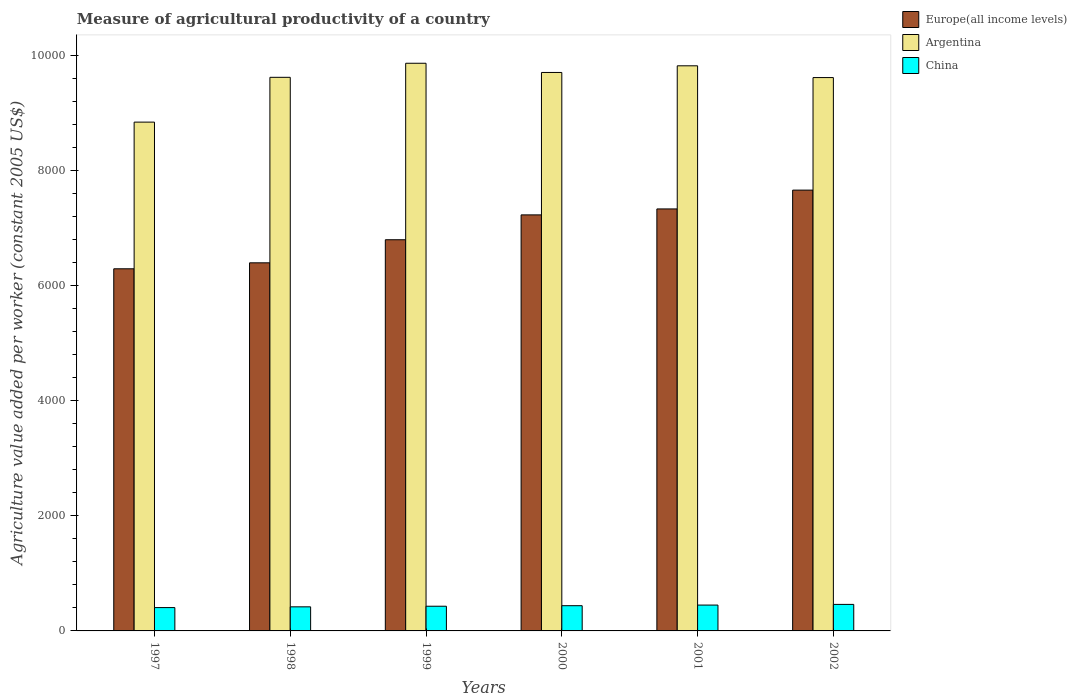How many groups of bars are there?
Offer a very short reply. 6. Are the number of bars on each tick of the X-axis equal?
Provide a succinct answer. Yes. What is the label of the 4th group of bars from the left?
Give a very brief answer. 2000. What is the measure of agricultural productivity in Argentina in 1998?
Provide a succinct answer. 9617.14. Across all years, what is the maximum measure of agricultural productivity in Argentina?
Offer a terse response. 9861.32. Across all years, what is the minimum measure of agricultural productivity in Argentina?
Keep it short and to the point. 8838.88. In which year was the measure of agricultural productivity in Argentina maximum?
Keep it short and to the point. 1999. What is the total measure of agricultural productivity in Europe(all income levels) in the graph?
Provide a succinct answer. 4.17e+04. What is the difference between the measure of agricultural productivity in China in 1998 and that in 2001?
Provide a short and direct response. -30.78. What is the difference between the measure of agricultural productivity in Europe(all income levels) in 1998 and the measure of agricultural productivity in Argentina in 2001?
Ensure brevity in your answer.  -3422.39. What is the average measure of agricultural productivity in Europe(all income levels) per year?
Your answer should be very brief. 6949.44. In the year 1999, what is the difference between the measure of agricultural productivity in China and measure of agricultural productivity in Argentina?
Your response must be concise. -9432.34. What is the ratio of the measure of agricultural productivity in Argentina in 1998 to that in 1999?
Provide a short and direct response. 0.98. Is the measure of agricultural productivity in Europe(all income levels) in 1998 less than that in 2001?
Your answer should be compact. Yes. What is the difference between the highest and the second highest measure of agricultural productivity in Argentina?
Give a very brief answer. 44.26. What is the difference between the highest and the lowest measure of agricultural productivity in Europe(all income levels)?
Provide a short and direct response. 1366.71. Is the sum of the measure of agricultural productivity in China in 1999 and 2002 greater than the maximum measure of agricultural productivity in Argentina across all years?
Your response must be concise. No. What does the 3rd bar from the left in 2001 represents?
Ensure brevity in your answer.  China. What does the 3rd bar from the right in 2001 represents?
Offer a terse response. Europe(all income levels). How many bars are there?
Provide a short and direct response. 18. How many years are there in the graph?
Your response must be concise. 6. What is the difference between two consecutive major ticks on the Y-axis?
Offer a very short reply. 2000. Are the values on the major ticks of Y-axis written in scientific E-notation?
Your answer should be compact. No. Does the graph contain any zero values?
Your answer should be compact. No. Where does the legend appear in the graph?
Keep it short and to the point. Top right. How many legend labels are there?
Make the answer very short. 3. How are the legend labels stacked?
Provide a succinct answer. Vertical. What is the title of the graph?
Offer a very short reply. Measure of agricultural productivity of a country. What is the label or title of the Y-axis?
Make the answer very short. Agriculture value added per worker (constant 2005 US$). What is the Agriculture value added per worker (constant 2005 US$) in Europe(all income levels) in 1997?
Provide a short and direct response. 6290.86. What is the Agriculture value added per worker (constant 2005 US$) in Argentina in 1997?
Your answer should be compact. 8838.88. What is the Agriculture value added per worker (constant 2005 US$) of China in 1997?
Offer a very short reply. 405.37. What is the Agriculture value added per worker (constant 2005 US$) in Europe(all income levels) in 1998?
Your answer should be very brief. 6394.67. What is the Agriculture value added per worker (constant 2005 US$) of Argentina in 1998?
Your answer should be compact. 9617.14. What is the Agriculture value added per worker (constant 2005 US$) in China in 1998?
Provide a succinct answer. 418.34. What is the Agriculture value added per worker (constant 2005 US$) of Europe(all income levels) in 1999?
Your answer should be compact. 6795.55. What is the Agriculture value added per worker (constant 2005 US$) in Argentina in 1999?
Offer a terse response. 9861.32. What is the Agriculture value added per worker (constant 2005 US$) of China in 1999?
Your response must be concise. 428.98. What is the Agriculture value added per worker (constant 2005 US$) of Europe(all income levels) in 2000?
Keep it short and to the point. 7227.25. What is the Agriculture value added per worker (constant 2005 US$) in Argentina in 2000?
Provide a short and direct response. 9701.56. What is the Agriculture value added per worker (constant 2005 US$) of China in 2000?
Your answer should be very brief. 438.12. What is the Agriculture value added per worker (constant 2005 US$) in Europe(all income levels) in 2001?
Provide a short and direct response. 7330.74. What is the Agriculture value added per worker (constant 2005 US$) of Argentina in 2001?
Your answer should be very brief. 9817.06. What is the Agriculture value added per worker (constant 2005 US$) of China in 2001?
Your answer should be very brief. 449.12. What is the Agriculture value added per worker (constant 2005 US$) in Europe(all income levels) in 2002?
Your response must be concise. 7657.57. What is the Agriculture value added per worker (constant 2005 US$) of Argentina in 2002?
Ensure brevity in your answer.  9612.59. What is the Agriculture value added per worker (constant 2005 US$) in China in 2002?
Give a very brief answer. 460.74. Across all years, what is the maximum Agriculture value added per worker (constant 2005 US$) in Europe(all income levels)?
Your answer should be compact. 7657.57. Across all years, what is the maximum Agriculture value added per worker (constant 2005 US$) of Argentina?
Give a very brief answer. 9861.32. Across all years, what is the maximum Agriculture value added per worker (constant 2005 US$) in China?
Offer a very short reply. 460.74. Across all years, what is the minimum Agriculture value added per worker (constant 2005 US$) of Europe(all income levels)?
Ensure brevity in your answer.  6290.86. Across all years, what is the minimum Agriculture value added per worker (constant 2005 US$) in Argentina?
Give a very brief answer. 8838.88. Across all years, what is the minimum Agriculture value added per worker (constant 2005 US$) of China?
Provide a succinct answer. 405.37. What is the total Agriculture value added per worker (constant 2005 US$) of Europe(all income levels) in the graph?
Offer a very short reply. 4.17e+04. What is the total Agriculture value added per worker (constant 2005 US$) in Argentina in the graph?
Your response must be concise. 5.74e+04. What is the total Agriculture value added per worker (constant 2005 US$) of China in the graph?
Your answer should be compact. 2600.67. What is the difference between the Agriculture value added per worker (constant 2005 US$) in Europe(all income levels) in 1997 and that in 1998?
Your answer should be very brief. -103.82. What is the difference between the Agriculture value added per worker (constant 2005 US$) in Argentina in 1997 and that in 1998?
Provide a short and direct response. -778.27. What is the difference between the Agriculture value added per worker (constant 2005 US$) of China in 1997 and that in 1998?
Offer a very short reply. -12.97. What is the difference between the Agriculture value added per worker (constant 2005 US$) in Europe(all income levels) in 1997 and that in 1999?
Ensure brevity in your answer.  -504.7. What is the difference between the Agriculture value added per worker (constant 2005 US$) in Argentina in 1997 and that in 1999?
Ensure brevity in your answer.  -1022.44. What is the difference between the Agriculture value added per worker (constant 2005 US$) in China in 1997 and that in 1999?
Keep it short and to the point. -23.61. What is the difference between the Agriculture value added per worker (constant 2005 US$) of Europe(all income levels) in 1997 and that in 2000?
Your answer should be compact. -936.4. What is the difference between the Agriculture value added per worker (constant 2005 US$) in Argentina in 1997 and that in 2000?
Keep it short and to the point. -862.69. What is the difference between the Agriculture value added per worker (constant 2005 US$) of China in 1997 and that in 2000?
Provide a short and direct response. -32.76. What is the difference between the Agriculture value added per worker (constant 2005 US$) in Europe(all income levels) in 1997 and that in 2001?
Make the answer very short. -1039.88. What is the difference between the Agriculture value added per worker (constant 2005 US$) in Argentina in 1997 and that in 2001?
Ensure brevity in your answer.  -978.18. What is the difference between the Agriculture value added per worker (constant 2005 US$) of China in 1997 and that in 2001?
Give a very brief answer. -43.75. What is the difference between the Agriculture value added per worker (constant 2005 US$) in Europe(all income levels) in 1997 and that in 2002?
Your answer should be compact. -1366.71. What is the difference between the Agriculture value added per worker (constant 2005 US$) in Argentina in 1997 and that in 2002?
Your answer should be very brief. -773.71. What is the difference between the Agriculture value added per worker (constant 2005 US$) of China in 1997 and that in 2002?
Give a very brief answer. -55.38. What is the difference between the Agriculture value added per worker (constant 2005 US$) of Europe(all income levels) in 1998 and that in 1999?
Offer a terse response. -400.88. What is the difference between the Agriculture value added per worker (constant 2005 US$) in Argentina in 1998 and that in 1999?
Offer a very short reply. -244.18. What is the difference between the Agriculture value added per worker (constant 2005 US$) in China in 1998 and that in 1999?
Your answer should be very brief. -10.64. What is the difference between the Agriculture value added per worker (constant 2005 US$) of Europe(all income levels) in 1998 and that in 2000?
Your answer should be compact. -832.58. What is the difference between the Agriculture value added per worker (constant 2005 US$) in Argentina in 1998 and that in 2000?
Your response must be concise. -84.42. What is the difference between the Agriculture value added per worker (constant 2005 US$) in China in 1998 and that in 2000?
Your answer should be compact. -19.78. What is the difference between the Agriculture value added per worker (constant 2005 US$) in Europe(all income levels) in 1998 and that in 2001?
Provide a short and direct response. -936.06. What is the difference between the Agriculture value added per worker (constant 2005 US$) in Argentina in 1998 and that in 2001?
Your answer should be very brief. -199.92. What is the difference between the Agriculture value added per worker (constant 2005 US$) in China in 1998 and that in 2001?
Offer a very short reply. -30.78. What is the difference between the Agriculture value added per worker (constant 2005 US$) in Europe(all income levels) in 1998 and that in 2002?
Provide a succinct answer. -1262.9. What is the difference between the Agriculture value added per worker (constant 2005 US$) in Argentina in 1998 and that in 2002?
Keep it short and to the point. 4.55. What is the difference between the Agriculture value added per worker (constant 2005 US$) of China in 1998 and that in 2002?
Your answer should be compact. -42.41. What is the difference between the Agriculture value added per worker (constant 2005 US$) of Europe(all income levels) in 1999 and that in 2000?
Offer a terse response. -431.7. What is the difference between the Agriculture value added per worker (constant 2005 US$) in Argentina in 1999 and that in 2000?
Your response must be concise. 159.75. What is the difference between the Agriculture value added per worker (constant 2005 US$) of China in 1999 and that in 2000?
Make the answer very short. -9.14. What is the difference between the Agriculture value added per worker (constant 2005 US$) of Europe(all income levels) in 1999 and that in 2001?
Offer a terse response. -535.18. What is the difference between the Agriculture value added per worker (constant 2005 US$) of Argentina in 1999 and that in 2001?
Provide a succinct answer. 44.26. What is the difference between the Agriculture value added per worker (constant 2005 US$) in China in 1999 and that in 2001?
Ensure brevity in your answer.  -20.14. What is the difference between the Agriculture value added per worker (constant 2005 US$) in Europe(all income levels) in 1999 and that in 2002?
Make the answer very short. -862.02. What is the difference between the Agriculture value added per worker (constant 2005 US$) in Argentina in 1999 and that in 2002?
Offer a very short reply. 248.73. What is the difference between the Agriculture value added per worker (constant 2005 US$) of China in 1999 and that in 2002?
Ensure brevity in your answer.  -31.77. What is the difference between the Agriculture value added per worker (constant 2005 US$) in Europe(all income levels) in 2000 and that in 2001?
Your answer should be very brief. -103.48. What is the difference between the Agriculture value added per worker (constant 2005 US$) in Argentina in 2000 and that in 2001?
Keep it short and to the point. -115.5. What is the difference between the Agriculture value added per worker (constant 2005 US$) in China in 2000 and that in 2001?
Give a very brief answer. -11. What is the difference between the Agriculture value added per worker (constant 2005 US$) of Europe(all income levels) in 2000 and that in 2002?
Your answer should be compact. -430.32. What is the difference between the Agriculture value added per worker (constant 2005 US$) in Argentina in 2000 and that in 2002?
Your answer should be compact. 88.97. What is the difference between the Agriculture value added per worker (constant 2005 US$) in China in 2000 and that in 2002?
Your answer should be very brief. -22.62. What is the difference between the Agriculture value added per worker (constant 2005 US$) of Europe(all income levels) in 2001 and that in 2002?
Make the answer very short. -326.84. What is the difference between the Agriculture value added per worker (constant 2005 US$) of Argentina in 2001 and that in 2002?
Make the answer very short. 204.47. What is the difference between the Agriculture value added per worker (constant 2005 US$) in China in 2001 and that in 2002?
Your answer should be compact. -11.62. What is the difference between the Agriculture value added per worker (constant 2005 US$) in Europe(all income levels) in 1997 and the Agriculture value added per worker (constant 2005 US$) in Argentina in 1998?
Your answer should be compact. -3326.29. What is the difference between the Agriculture value added per worker (constant 2005 US$) in Europe(all income levels) in 1997 and the Agriculture value added per worker (constant 2005 US$) in China in 1998?
Your answer should be compact. 5872.52. What is the difference between the Agriculture value added per worker (constant 2005 US$) of Argentina in 1997 and the Agriculture value added per worker (constant 2005 US$) of China in 1998?
Ensure brevity in your answer.  8420.54. What is the difference between the Agriculture value added per worker (constant 2005 US$) of Europe(all income levels) in 1997 and the Agriculture value added per worker (constant 2005 US$) of Argentina in 1999?
Ensure brevity in your answer.  -3570.46. What is the difference between the Agriculture value added per worker (constant 2005 US$) in Europe(all income levels) in 1997 and the Agriculture value added per worker (constant 2005 US$) in China in 1999?
Make the answer very short. 5861.88. What is the difference between the Agriculture value added per worker (constant 2005 US$) in Argentina in 1997 and the Agriculture value added per worker (constant 2005 US$) in China in 1999?
Give a very brief answer. 8409.9. What is the difference between the Agriculture value added per worker (constant 2005 US$) of Europe(all income levels) in 1997 and the Agriculture value added per worker (constant 2005 US$) of Argentina in 2000?
Give a very brief answer. -3410.71. What is the difference between the Agriculture value added per worker (constant 2005 US$) in Europe(all income levels) in 1997 and the Agriculture value added per worker (constant 2005 US$) in China in 2000?
Your answer should be very brief. 5852.73. What is the difference between the Agriculture value added per worker (constant 2005 US$) in Argentina in 1997 and the Agriculture value added per worker (constant 2005 US$) in China in 2000?
Ensure brevity in your answer.  8400.75. What is the difference between the Agriculture value added per worker (constant 2005 US$) in Europe(all income levels) in 1997 and the Agriculture value added per worker (constant 2005 US$) in Argentina in 2001?
Offer a terse response. -3526.2. What is the difference between the Agriculture value added per worker (constant 2005 US$) in Europe(all income levels) in 1997 and the Agriculture value added per worker (constant 2005 US$) in China in 2001?
Your answer should be very brief. 5841.74. What is the difference between the Agriculture value added per worker (constant 2005 US$) of Argentina in 1997 and the Agriculture value added per worker (constant 2005 US$) of China in 2001?
Offer a very short reply. 8389.76. What is the difference between the Agriculture value added per worker (constant 2005 US$) of Europe(all income levels) in 1997 and the Agriculture value added per worker (constant 2005 US$) of Argentina in 2002?
Ensure brevity in your answer.  -3321.73. What is the difference between the Agriculture value added per worker (constant 2005 US$) in Europe(all income levels) in 1997 and the Agriculture value added per worker (constant 2005 US$) in China in 2002?
Make the answer very short. 5830.11. What is the difference between the Agriculture value added per worker (constant 2005 US$) of Argentina in 1997 and the Agriculture value added per worker (constant 2005 US$) of China in 2002?
Your answer should be very brief. 8378.13. What is the difference between the Agriculture value added per worker (constant 2005 US$) in Europe(all income levels) in 1998 and the Agriculture value added per worker (constant 2005 US$) in Argentina in 1999?
Your response must be concise. -3466.64. What is the difference between the Agriculture value added per worker (constant 2005 US$) of Europe(all income levels) in 1998 and the Agriculture value added per worker (constant 2005 US$) of China in 1999?
Your answer should be very brief. 5965.69. What is the difference between the Agriculture value added per worker (constant 2005 US$) of Argentina in 1998 and the Agriculture value added per worker (constant 2005 US$) of China in 1999?
Your answer should be very brief. 9188.16. What is the difference between the Agriculture value added per worker (constant 2005 US$) of Europe(all income levels) in 1998 and the Agriculture value added per worker (constant 2005 US$) of Argentina in 2000?
Your answer should be compact. -3306.89. What is the difference between the Agriculture value added per worker (constant 2005 US$) of Europe(all income levels) in 1998 and the Agriculture value added per worker (constant 2005 US$) of China in 2000?
Your answer should be very brief. 5956.55. What is the difference between the Agriculture value added per worker (constant 2005 US$) of Argentina in 1998 and the Agriculture value added per worker (constant 2005 US$) of China in 2000?
Keep it short and to the point. 9179.02. What is the difference between the Agriculture value added per worker (constant 2005 US$) in Europe(all income levels) in 1998 and the Agriculture value added per worker (constant 2005 US$) in Argentina in 2001?
Offer a very short reply. -3422.39. What is the difference between the Agriculture value added per worker (constant 2005 US$) of Europe(all income levels) in 1998 and the Agriculture value added per worker (constant 2005 US$) of China in 2001?
Give a very brief answer. 5945.55. What is the difference between the Agriculture value added per worker (constant 2005 US$) of Argentina in 1998 and the Agriculture value added per worker (constant 2005 US$) of China in 2001?
Your response must be concise. 9168.02. What is the difference between the Agriculture value added per worker (constant 2005 US$) in Europe(all income levels) in 1998 and the Agriculture value added per worker (constant 2005 US$) in Argentina in 2002?
Your answer should be compact. -3217.92. What is the difference between the Agriculture value added per worker (constant 2005 US$) of Europe(all income levels) in 1998 and the Agriculture value added per worker (constant 2005 US$) of China in 2002?
Your answer should be very brief. 5933.93. What is the difference between the Agriculture value added per worker (constant 2005 US$) of Argentina in 1998 and the Agriculture value added per worker (constant 2005 US$) of China in 2002?
Ensure brevity in your answer.  9156.4. What is the difference between the Agriculture value added per worker (constant 2005 US$) in Europe(all income levels) in 1999 and the Agriculture value added per worker (constant 2005 US$) in Argentina in 2000?
Your response must be concise. -2906.01. What is the difference between the Agriculture value added per worker (constant 2005 US$) of Europe(all income levels) in 1999 and the Agriculture value added per worker (constant 2005 US$) of China in 2000?
Keep it short and to the point. 6357.43. What is the difference between the Agriculture value added per worker (constant 2005 US$) in Argentina in 1999 and the Agriculture value added per worker (constant 2005 US$) in China in 2000?
Your response must be concise. 9423.2. What is the difference between the Agriculture value added per worker (constant 2005 US$) in Europe(all income levels) in 1999 and the Agriculture value added per worker (constant 2005 US$) in Argentina in 2001?
Ensure brevity in your answer.  -3021.51. What is the difference between the Agriculture value added per worker (constant 2005 US$) of Europe(all income levels) in 1999 and the Agriculture value added per worker (constant 2005 US$) of China in 2001?
Keep it short and to the point. 6346.43. What is the difference between the Agriculture value added per worker (constant 2005 US$) of Argentina in 1999 and the Agriculture value added per worker (constant 2005 US$) of China in 2001?
Offer a very short reply. 9412.2. What is the difference between the Agriculture value added per worker (constant 2005 US$) of Europe(all income levels) in 1999 and the Agriculture value added per worker (constant 2005 US$) of Argentina in 2002?
Keep it short and to the point. -2817.04. What is the difference between the Agriculture value added per worker (constant 2005 US$) in Europe(all income levels) in 1999 and the Agriculture value added per worker (constant 2005 US$) in China in 2002?
Make the answer very short. 6334.81. What is the difference between the Agriculture value added per worker (constant 2005 US$) in Argentina in 1999 and the Agriculture value added per worker (constant 2005 US$) in China in 2002?
Offer a very short reply. 9400.57. What is the difference between the Agriculture value added per worker (constant 2005 US$) in Europe(all income levels) in 2000 and the Agriculture value added per worker (constant 2005 US$) in Argentina in 2001?
Offer a terse response. -2589.81. What is the difference between the Agriculture value added per worker (constant 2005 US$) of Europe(all income levels) in 2000 and the Agriculture value added per worker (constant 2005 US$) of China in 2001?
Ensure brevity in your answer.  6778.13. What is the difference between the Agriculture value added per worker (constant 2005 US$) of Argentina in 2000 and the Agriculture value added per worker (constant 2005 US$) of China in 2001?
Your response must be concise. 9252.44. What is the difference between the Agriculture value added per worker (constant 2005 US$) in Europe(all income levels) in 2000 and the Agriculture value added per worker (constant 2005 US$) in Argentina in 2002?
Make the answer very short. -2385.34. What is the difference between the Agriculture value added per worker (constant 2005 US$) of Europe(all income levels) in 2000 and the Agriculture value added per worker (constant 2005 US$) of China in 2002?
Keep it short and to the point. 6766.51. What is the difference between the Agriculture value added per worker (constant 2005 US$) of Argentina in 2000 and the Agriculture value added per worker (constant 2005 US$) of China in 2002?
Offer a terse response. 9240.82. What is the difference between the Agriculture value added per worker (constant 2005 US$) in Europe(all income levels) in 2001 and the Agriculture value added per worker (constant 2005 US$) in Argentina in 2002?
Make the answer very short. -2281.85. What is the difference between the Agriculture value added per worker (constant 2005 US$) in Europe(all income levels) in 2001 and the Agriculture value added per worker (constant 2005 US$) in China in 2002?
Make the answer very short. 6869.99. What is the difference between the Agriculture value added per worker (constant 2005 US$) in Argentina in 2001 and the Agriculture value added per worker (constant 2005 US$) in China in 2002?
Ensure brevity in your answer.  9356.32. What is the average Agriculture value added per worker (constant 2005 US$) in Europe(all income levels) per year?
Offer a very short reply. 6949.44. What is the average Agriculture value added per worker (constant 2005 US$) of Argentina per year?
Your answer should be very brief. 9574.76. What is the average Agriculture value added per worker (constant 2005 US$) in China per year?
Provide a succinct answer. 433.44. In the year 1997, what is the difference between the Agriculture value added per worker (constant 2005 US$) in Europe(all income levels) and Agriculture value added per worker (constant 2005 US$) in Argentina?
Keep it short and to the point. -2548.02. In the year 1997, what is the difference between the Agriculture value added per worker (constant 2005 US$) in Europe(all income levels) and Agriculture value added per worker (constant 2005 US$) in China?
Your response must be concise. 5885.49. In the year 1997, what is the difference between the Agriculture value added per worker (constant 2005 US$) in Argentina and Agriculture value added per worker (constant 2005 US$) in China?
Make the answer very short. 8433.51. In the year 1998, what is the difference between the Agriculture value added per worker (constant 2005 US$) in Europe(all income levels) and Agriculture value added per worker (constant 2005 US$) in Argentina?
Offer a very short reply. -3222.47. In the year 1998, what is the difference between the Agriculture value added per worker (constant 2005 US$) of Europe(all income levels) and Agriculture value added per worker (constant 2005 US$) of China?
Provide a short and direct response. 5976.34. In the year 1998, what is the difference between the Agriculture value added per worker (constant 2005 US$) in Argentina and Agriculture value added per worker (constant 2005 US$) in China?
Your answer should be very brief. 9198.8. In the year 1999, what is the difference between the Agriculture value added per worker (constant 2005 US$) of Europe(all income levels) and Agriculture value added per worker (constant 2005 US$) of Argentina?
Keep it short and to the point. -3065.77. In the year 1999, what is the difference between the Agriculture value added per worker (constant 2005 US$) in Europe(all income levels) and Agriculture value added per worker (constant 2005 US$) in China?
Your answer should be compact. 6366.57. In the year 1999, what is the difference between the Agriculture value added per worker (constant 2005 US$) of Argentina and Agriculture value added per worker (constant 2005 US$) of China?
Your response must be concise. 9432.34. In the year 2000, what is the difference between the Agriculture value added per worker (constant 2005 US$) of Europe(all income levels) and Agriculture value added per worker (constant 2005 US$) of Argentina?
Ensure brevity in your answer.  -2474.31. In the year 2000, what is the difference between the Agriculture value added per worker (constant 2005 US$) in Europe(all income levels) and Agriculture value added per worker (constant 2005 US$) in China?
Keep it short and to the point. 6789.13. In the year 2000, what is the difference between the Agriculture value added per worker (constant 2005 US$) in Argentina and Agriculture value added per worker (constant 2005 US$) in China?
Your answer should be very brief. 9263.44. In the year 2001, what is the difference between the Agriculture value added per worker (constant 2005 US$) of Europe(all income levels) and Agriculture value added per worker (constant 2005 US$) of Argentina?
Provide a short and direct response. -2486.32. In the year 2001, what is the difference between the Agriculture value added per worker (constant 2005 US$) of Europe(all income levels) and Agriculture value added per worker (constant 2005 US$) of China?
Provide a short and direct response. 6881.62. In the year 2001, what is the difference between the Agriculture value added per worker (constant 2005 US$) in Argentina and Agriculture value added per worker (constant 2005 US$) in China?
Offer a terse response. 9367.94. In the year 2002, what is the difference between the Agriculture value added per worker (constant 2005 US$) of Europe(all income levels) and Agriculture value added per worker (constant 2005 US$) of Argentina?
Keep it short and to the point. -1955.02. In the year 2002, what is the difference between the Agriculture value added per worker (constant 2005 US$) in Europe(all income levels) and Agriculture value added per worker (constant 2005 US$) in China?
Your response must be concise. 7196.83. In the year 2002, what is the difference between the Agriculture value added per worker (constant 2005 US$) of Argentina and Agriculture value added per worker (constant 2005 US$) of China?
Keep it short and to the point. 9151.85. What is the ratio of the Agriculture value added per worker (constant 2005 US$) of Europe(all income levels) in 1997 to that in 1998?
Your answer should be very brief. 0.98. What is the ratio of the Agriculture value added per worker (constant 2005 US$) of Argentina in 1997 to that in 1998?
Provide a succinct answer. 0.92. What is the ratio of the Agriculture value added per worker (constant 2005 US$) of China in 1997 to that in 1998?
Ensure brevity in your answer.  0.97. What is the ratio of the Agriculture value added per worker (constant 2005 US$) of Europe(all income levels) in 1997 to that in 1999?
Ensure brevity in your answer.  0.93. What is the ratio of the Agriculture value added per worker (constant 2005 US$) of Argentina in 1997 to that in 1999?
Provide a succinct answer. 0.9. What is the ratio of the Agriculture value added per worker (constant 2005 US$) in China in 1997 to that in 1999?
Your answer should be compact. 0.94. What is the ratio of the Agriculture value added per worker (constant 2005 US$) of Europe(all income levels) in 1997 to that in 2000?
Provide a short and direct response. 0.87. What is the ratio of the Agriculture value added per worker (constant 2005 US$) of Argentina in 1997 to that in 2000?
Your answer should be compact. 0.91. What is the ratio of the Agriculture value added per worker (constant 2005 US$) in China in 1997 to that in 2000?
Your response must be concise. 0.93. What is the ratio of the Agriculture value added per worker (constant 2005 US$) in Europe(all income levels) in 1997 to that in 2001?
Your answer should be compact. 0.86. What is the ratio of the Agriculture value added per worker (constant 2005 US$) in Argentina in 1997 to that in 2001?
Ensure brevity in your answer.  0.9. What is the ratio of the Agriculture value added per worker (constant 2005 US$) in China in 1997 to that in 2001?
Offer a terse response. 0.9. What is the ratio of the Agriculture value added per worker (constant 2005 US$) of Europe(all income levels) in 1997 to that in 2002?
Provide a short and direct response. 0.82. What is the ratio of the Agriculture value added per worker (constant 2005 US$) in Argentina in 1997 to that in 2002?
Offer a terse response. 0.92. What is the ratio of the Agriculture value added per worker (constant 2005 US$) of China in 1997 to that in 2002?
Offer a very short reply. 0.88. What is the ratio of the Agriculture value added per worker (constant 2005 US$) of Europe(all income levels) in 1998 to that in 1999?
Make the answer very short. 0.94. What is the ratio of the Agriculture value added per worker (constant 2005 US$) in Argentina in 1998 to that in 1999?
Make the answer very short. 0.98. What is the ratio of the Agriculture value added per worker (constant 2005 US$) of China in 1998 to that in 1999?
Your answer should be very brief. 0.98. What is the ratio of the Agriculture value added per worker (constant 2005 US$) of Europe(all income levels) in 1998 to that in 2000?
Make the answer very short. 0.88. What is the ratio of the Agriculture value added per worker (constant 2005 US$) in China in 1998 to that in 2000?
Your answer should be compact. 0.95. What is the ratio of the Agriculture value added per worker (constant 2005 US$) in Europe(all income levels) in 1998 to that in 2001?
Your answer should be very brief. 0.87. What is the ratio of the Agriculture value added per worker (constant 2005 US$) of Argentina in 1998 to that in 2001?
Your response must be concise. 0.98. What is the ratio of the Agriculture value added per worker (constant 2005 US$) in China in 1998 to that in 2001?
Offer a terse response. 0.93. What is the ratio of the Agriculture value added per worker (constant 2005 US$) in Europe(all income levels) in 1998 to that in 2002?
Provide a short and direct response. 0.84. What is the ratio of the Agriculture value added per worker (constant 2005 US$) of Argentina in 1998 to that in 2002?
Give a very brief answer. 1. What is the ratio of the Agriculture value added per worker (constant 2005 US$) of China in 1998 to that in 2002?
Your answer should be very brief. 0.91. What is the ratio of the Agriculture value added per worker (constant 2005 US$) of Europe(all income levels) in 1999 to that in 2000?
Offer a terse response. 0.94. What is the ratio of the Agriculture value added per worker (constant 2005 US$) of Argentina in 1999 to that in 2000?
Offer a terse response. 1.02. What is the ratio of the Agriculture value added per worker (constant 2005 US$) of China in 1999 to that in 2000?
Offer a terse response. 0.98. What is the ratio of the Agriculture value added per worker (constant 2005 US$) in Europe(all income levels) in 1999 to that in 2001?
Keep it short and to the point. 0.93. What is the ratio of the Agriculture value added per worker (constant 2005 US$) in Argentina in 1999 to that in 2001?
Provide a succinct answer. 1. What is the ratio of the Agriculture value added per worker (constant 2005 US$) in China in 1999 to that in 2001?
Your answer should be very brief. 0.96. What is the ratio of the Agriculture value added per worker (constant 2005 US$) of Europe(all income levels) in 1999 to that in 2002?
Make the answer very short. 0.89. What is the ratio of the Agriculture value added per worker (constant 2005 US$) of Argentina in 1999 to that in 2002?
Provide a short and direct response. 1.03. What is the ratio of the Agriculture value added per worker (constant 2005 US$) of China in 1999 to that in 2002?
Your answer should be very brief. 0.93. What is the ratio of the Agriculture value added per worker (constant 2005 US$) of Europe(all income levels) in 2000 to that in 2001?
Your response must be concise. 0.99. What is the ratio of the Agriculture value added per worker (constant 2005 US$) in Argentina in 2000 to that in 2001?
Give a very brief answer. 0.99. What is the ratio of the Agriculture value added per worker (constant 2005 US$) in China in 2000 to that in 2001?
Ensure brevity in your answer.  0.98. What is the ratio of the Agriculture value added per worker (constant 2005 US$) in Europe(all income levels) in 2000 to that in 2002?
Your response must be concise. 0.94. What is the ratio of the Agriculture value added per worker (constant 2005 US$) of Argentina in 2000 to that in 2002?
Your answer should be very brief. 1.01. What is the ratio of the Agriculture value added per worker (constant 2005 US$) in China in 2000 to that in 2002?
Offer a very short reply. 0.95. What is the ratio of the Agriculture value added per worker (constant 2005 US$) of Europe(all income levels) in 2001 to that in 2002?
Provide a short and direct response. 0.96. What is the ratio of the Agriculture value added per worker (constant 2005 US$) in Argentina in 2001 to that in 2002?
Give a very brief answer. 1.02. What is the ratio of the Agriculture value added per worker (constant 2005 US$) of China in 2001 to that in 2002?
Ensure brevity in your answer.  0.97. What is the difference between the highest and the second highest Agriculture value added per worker (constant 2005 US$) of Europe(all income levels)?
Provide a succinct answer. 326.84. What is the difference between the highest and the second highest Agriculture value added per worker (constant 2005 US$) in Argentina?
Keep it short and to the point. 44.26. What is the difference between the highest and the second highest Agriculture value added per worker (constant 2005 US$) of China?
Make the answer very short. 11.62. What is the difference between the highest and the lowest Agriculture value added per worker (constant 2005 US$) in Europe(all income levels)?
Give a very brief answer. 1366.71. What is the difference between the highest and the lowest Agriculture value added per worker (constant 2005 US$) in Argentina?
Your answer should be compact. 1022.44. What is the difference between the highest and the lowest Agriculture value added per worker (constant 2005 US$) of China?
Your answer should be very brief. 55.38. 